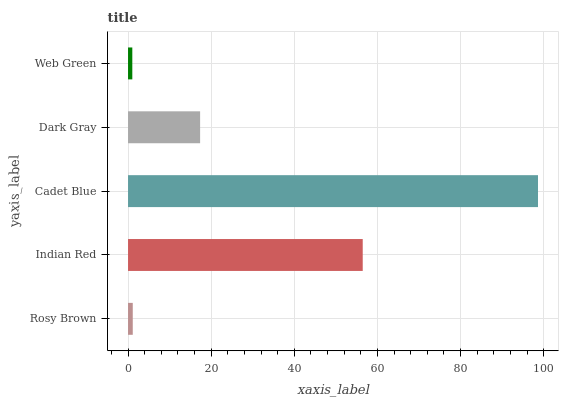Is Web Green the minimum?
Answer yes or no. Yes. Is Cadet Blue the maximum?
Answer yes or no. Yes. Is Indian Red the minimum?
Answer yes or no. No. Is Indian Red the maximum?
Answer yes or no. No. Is Indian Red greater than Rosy Brown?
Answer yes or no. Yes. Is Rosy Brown less than Indian Red?
Answer yes or no. Yes. Is Rosy Brown greater than Indian Red?
Answer yes or no. No. Is Indian Red less than Rosy Brown?
Answer yes or no. No. Is Dark Gray the high median?
Answer yes or no. Yes. Is Dark Gray the low median?
Answer yes or no. Yes. Is Indian Red the high median?
Answer yes or no. No. Is Web Green the low median?
Answer yes or no. No. 